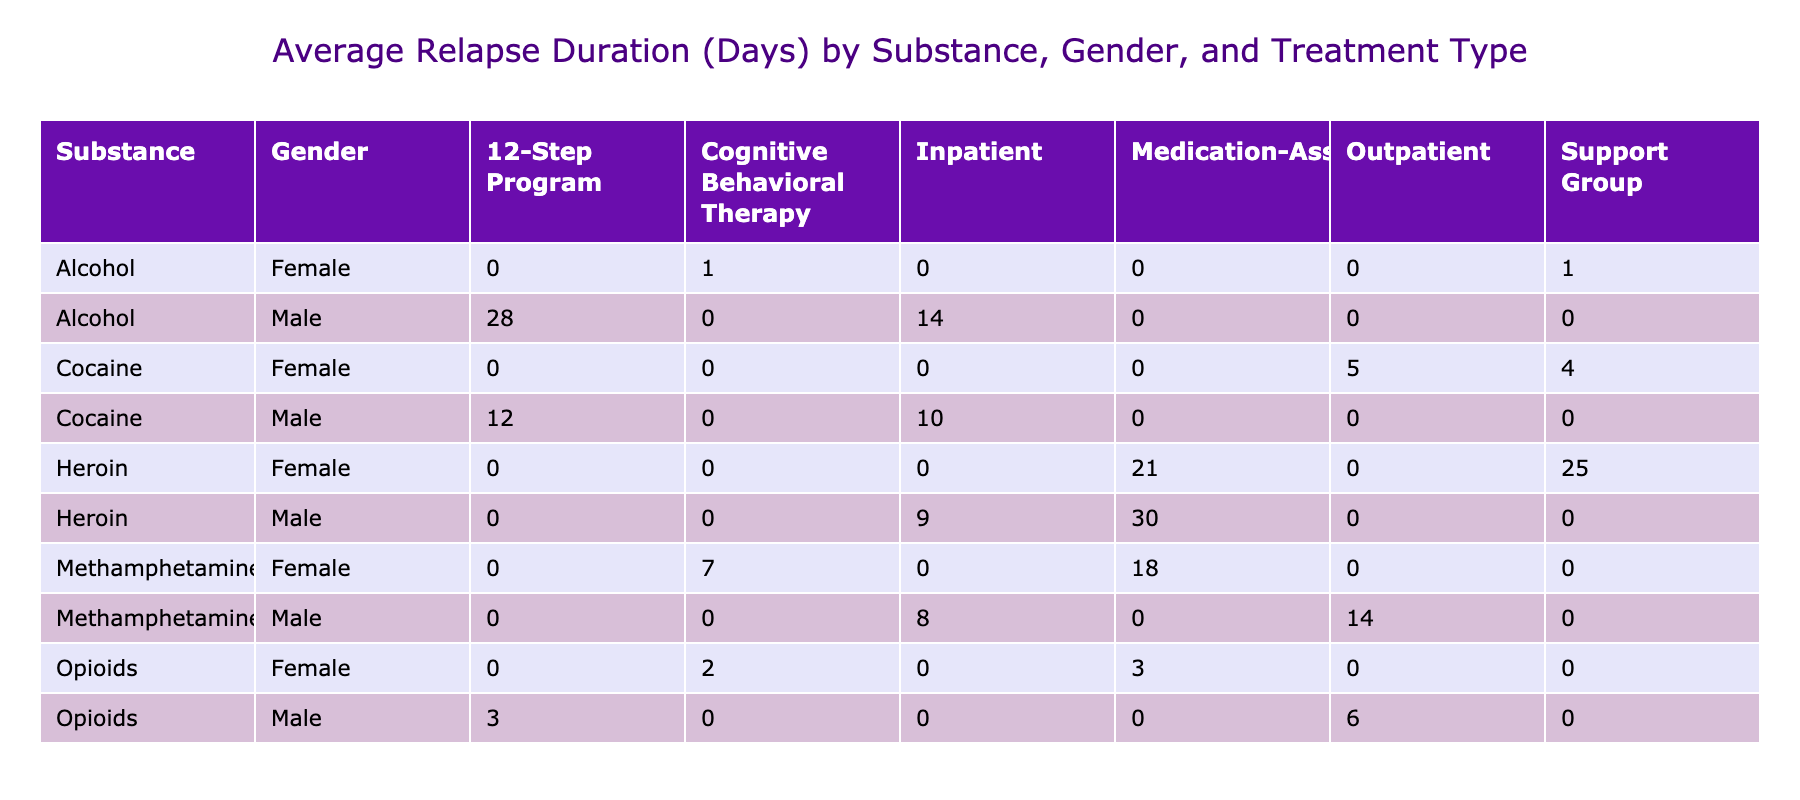What is the average relapse duration for female patients undergoing Medication-Assisted treatment for heroin addiction? Looking at the table, the relapse duration for female patients with heroin addiction who underwent Medication-Assisted treatment is 25 days. Therefore, the average is 25 days.
Answer: 25 days How does the average relapse duration for males compare between the 12-Step Program and Cognitive Behavioral Therapy for alcohol abuse? The average relapse duration for male patients in the 12-Step Program for alcohol is 28 days, while for those in Cognitive Behavioral Therapy, it is 1 day. The difference is 28 - 1, which equals 27 days.
Answer: 27 days Is there any male patient who had a longer average relapse duration in outpatient treatment compared to those in inpatient treatment for cocaine? For cocaine, the male patient under outpatient treatment had an average relapse duration of 0 days (not listed in the table), while the male in inpatient treatment had a duration of 10 days. So, there is no male patient with a longer duration in outpatient than in inpatient treatment.
Answer: No What is the average relapse duration for females in the outpatient treatment category across all substances? In the outpatient treatment category, the relapse durations for female patients are 7 days (methamphetamine) and 6 days (opioids). To calculate the average, sum them up (7 + 6) = 13 and divide by 2, which gives us 13/2 = 6.5 days.
Answer: 6.5 days Among all treatment types, which substance has the highest average relapse duration for male patients? Looking across all treatment types for male patients, the highest average relapse duration is seen with cocaine inpatient treatment at 10 days and alcohol with 28 days in the 12-Step Program. Comparing the two, alcohol has the highest average relapse duration for male patients, which is 28 days.
Answer: Alcohol (28 days) 